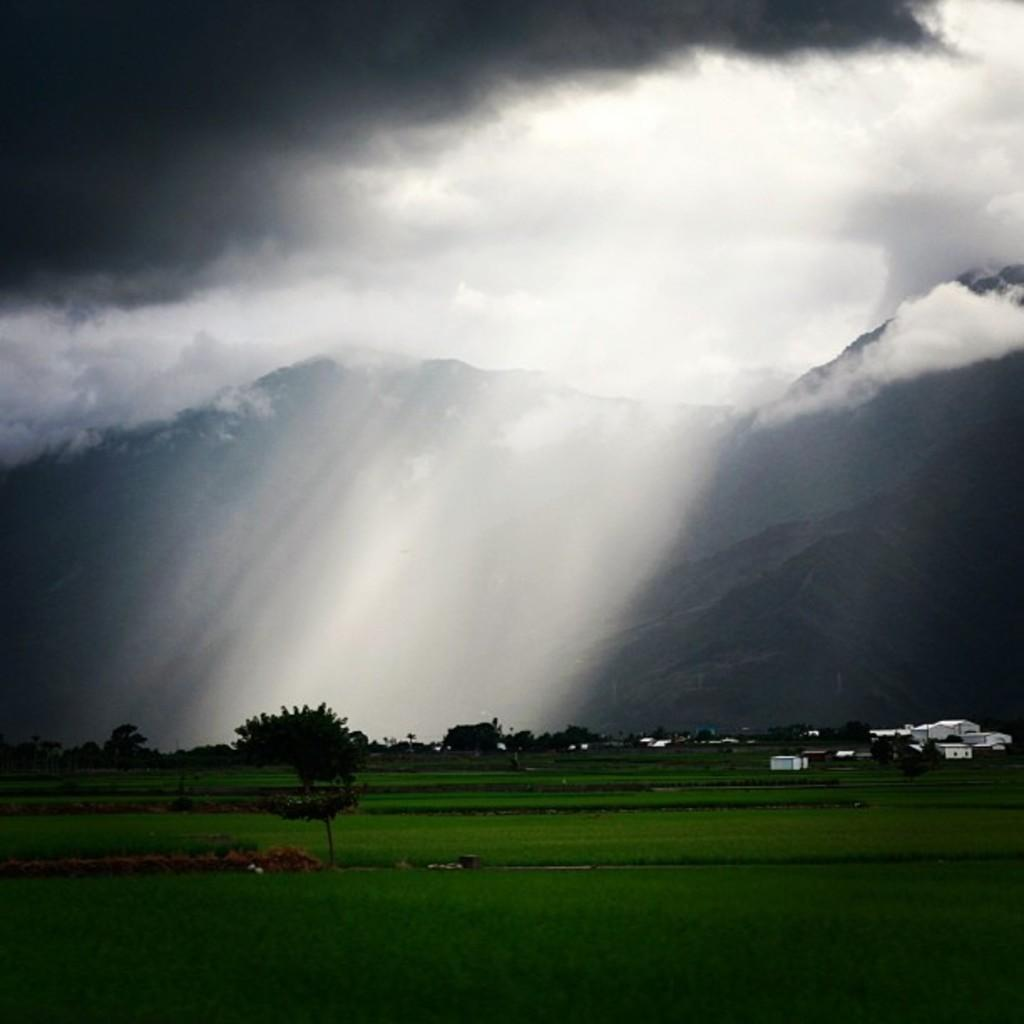What type of vegetation is visible in the image? There is grass in the image. What other natural elements can be seen in the image? There are trees in the image. Are there any man-made structures visible? Yes, there are buildings in the image. What type of landscape feature is present in the image? There are mountains in the image. What else can be seen in the image besides the grass, trees, buildings, and mountains? There are objects in the image. What is visible in the background of the image? The sky is visible in the background of the image. Can you describe the sky in the image? Clouds are present in the sky. What type of apple is being used to represent peace in the image? There is no apple present in the image, and the concept of peace is not depicted. 